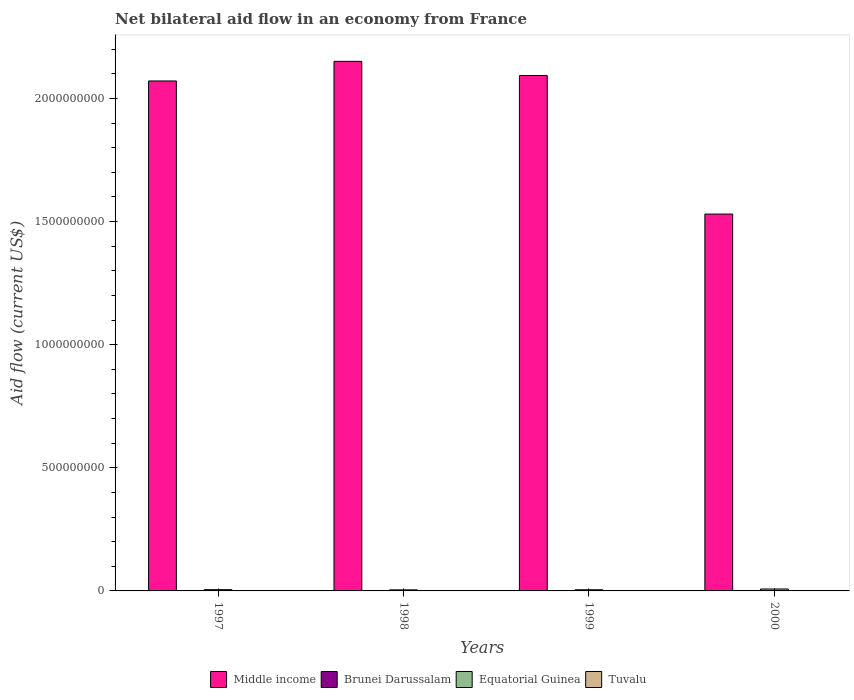How many bars are there on the 1st tick from the left?
Keep it short and to the point. 4. What is the net bilateral aid flow in Middle income in 1997?
Keep it short and to the point. 2.07e+09. Across all years, what is the minimum net bilateral aid flow in Equatorial Guinea?
Your response must be concise. 4.35e+06. What is the total net bilateral aid flow in Brunei Darussalam in the graph?
Ensure brevity in your answer.  1.51e+06. What is the difference between the net bilateral aid flow in Equatorial Guinea in 2000 and the net bilateral aid flow in Middle income in 1997?
Offer a terse response. -2.06e+09. What is the average net bilateral aid flow in Tuvalu per year?
Make the answer very short. 2.40e+05. In the year 1997, what is the difference between the net bilateral aid flow in Middle income and net bilateral aid flow in Tuvalu?
Provide a succinct answer. 2.07e+09. What is the ratio of the net bilateral aid flow in Equatorial Guinea in 1997 to that in 2000?
Make the answer very short. 0.66. Is the difference between the net bilateral aid flow in Middle income in 1998 and 2000 greater than the difference between the net bilateral aid flow in Tuvalu in 1998 and 2000?
Offer a very short reply. Yes. What is the difference between the highest and the second highest net bilateral aid flow in Tuvalu?
Make the answer very short. 10000. What is the difference between the highest and the lowest net bilateral aid flow in Equatorial Guinea?
Give a very brief answer. 3.53e+06. In how many years, is the net bilateral aid flow in Brunei Darussalam greater than the average net bilateral aid flow in Brunei Darussalam taken over all years?
Your response must be concise. 1. Is the sum of the net bilateral aid flow in Tuvalu in 1998 and 1999 greater than the maximum net bilateral aid flow in Brunei Darussalam across all years?
Offer a very short reply. No. What does the 3rd bar from the left in 1998 represents?
Your answer should be very brief. Equatorial Guinea. What does the 2nd bar from the right in 1998 represents?
Your answer should be very brief. Equatorial Guinea. Is it the case that in every year, the sum of the net bilateral aid flow in Middle income and net bilateral aid flow in Tuvalu is greater than the net bilateral aid flow in Brunei Darussalam?
Provide a short and direct response. Yes. Are all the bars in the graph horizontal?
Make the answer very short. No. Does the graph contain any zero values?
Give a very brief answer. No. Does the graph contain grids?
Keep it short and to the point. No. How many legend labels are there?
Your response must be concise. 4. What is the title of the graph?
Your response must be concise. Net bilateral aid flow in an economy from France. What is the Aid flow (current US$) of Middle income in 1997?
Provide a short and direct response. 2.07e+09. What is the Aid flow (current US$) in Equatorial Guinea in 1997?
Provide a succinct answer. 5.18e+06. What is the Aid flow (current US$) in Tuvalu in 1997?
Make the answer very short. 1.30e+05. What is the Aid flow (current US$) of Middle income in 1998?
Make the answer very short. 2.15e+09. What is the Aid flow (current US$) in Brunei Darussalam in 1998?
Offer a very short reply. 1.00e+05. What is the Aid flow (current US$) of Equatorial Guinea in 1998?
Your answer should be compact. 4.35e+06. What is the Aid flow (current US$) of Tuvalu in 1998?
Offer a very short reply. 2.80e+05. What is the Aid flow (current US$) in Middle income in 1999?
Your answer should be compact. 2.09e+09. What is the Aid flow (current US$) in Brunei Darussalam in 1999?
Your answer should be compact. 1.24e+06. What is the Aid flow (current US$) in Equatorial Guinea in 1999?
Ensure brevity in your answer.  4.74e+06. What is the Aid flow (current US$) of Middle income in 2000?
Offer a very short reply. 1.53e+09. What is the Aid flow (current US$) of Equatorial Guinea in 2000?
Your answer should be compact. 7.88e+06. Across all years, what is the maximum Aid flow (current US$) in Middle income?
Your answer should be compact. 2.15e+09. Across all years, what is the maximum Aid flow (current US$) in Brunei Darussalam?
Provide a succinct answer. 1.24e+06. Across all years, what is the maximum Aid flow (current US$) of Equatorial Guinea?
Provide a short and direct response. 7.88e+06. Across all years, what is the minimum Aid flow (current US$) in Middle income?
Your answer should be very brief. 1.53e+09. Across all years, what is the minimum Aid flow (current US$) of Equatorial Guinea?
Your answer should be compact. 4.35e+06. What is the total Aid flow (current US$) of Middle income in the graph?
Your answer should be very brief. 7.84e+09. What is the total Aid flow (current US$) of Brunei Darussalam in the graph?
Give a very brief answer. 1.51e+06. What is the total Aid flow (current US$) of Equatorial Guinea in the graph?
Your answer should be compact. 2.22e+07. What is the total Aid flow (current US$) in Tuvalu in the graph?
Ensure brevity in your answer.  9.60e+05. What is the difference between the Aid flow (current US$) of Middle income in 1997 and that in 1998?
Ensure brevity in your answer.  -7.96e+07. What is the difference between the Aid flow (current US$) of Equatorial Guinea in 1997 and that in 1998?
Offer a very short reply. 8.30e+05. What is the difference between the Aid flow (current US$) in Middle income in 1997 and that in 1999?
Make the answer very short. -2.21e+07. What is the difference between the Aid flow (current US$) in Brunei Darussalam in 1997 and that in 1999?
Keep it short and to the point. -1.17e+06. What is the difference between the Aid flow (current US$) in Equatorial Guinea in 1997 and that in 1999?
Ensure brevity in your answer.  4.40e+05. What is the difference between the Aid flow (current US$) in Tuvalu in 1997 and that in 1999?
Provide a short and direct response. -1.30e+05. What is the difference between the Aid flow (current US$) in Middle income in 1997 and that in 2000?
Offer a very short reply. 5.40e+08. What is the difference between the Aid flow (current US$) of Brunei Darussalam in 1997 and that in 2000?
Keep it short and to the point. -3.00e+04. What is the difference between the Aid flow (current US$) of Equatorial Guinea in 1997 and that in 2000?
Offer a very short reply. -2.70e+06. What is the difference between the Aid flow (current US$) in Middle income in 1998 and that in 1999?
Ensure brevity in your answer.  5.75e+07. What is the difference between the Aid flow (current US$) in Brunei Darussalam in 1998 and that in 1999?
Ensure brevity in your answer.  -1.14e+06. What is the difference between the Aid flow (current US$) of Equatorial Guinea in 1998 and that in 1999?
Ensure brevity in your answer.  -3.90e+05. What is the difference between the Aid flow (current US$) of Tuvalu in 1998 and that in 1999?
Your answer should be compact. 2.00e+04. What is the difference between the Aid flow (current US$) of Middle income in 1998 and that in 2000?
Give a very brief answer. 6.20e+08. What is the difference between the Aid flow (current US$) of Equatorial Guinea in 1998 and that in 2000?
Ensure brevity in your answer.  -3.53e+06. What is the difference between the Aid flow (current US$) of Middle income in 1999 and that in 2000?
Give a very brief answer. 5.63e+08. What is the difference between the Aid flow (current US$) in Brunei Darussalam in 1999 and that in 2000?
Your answer should be very brief. 1.14e+06. What is the difference between the Aid flow (current US$) in Equatorial Guinea in 1999 and that in 2000?
Keep it short and to the point. -3.14e+06. What is the difference between the Aid flow (current US$) of Tuvalu in 1999 and that in 2000?
Your answer should be compact. -3.00e+04. What is the difference between the Aid flow (current US$) of Middle income in 1997 and the Aid flow (current US$) of Brunei Darussalam in 1998?
Offer a very short reply. 2.07e+09. What is the difference between the Aid flow (current US$) in Middle income in 1997 and the Aid flow (current US$) in Equatorial Guinea in 1998?
Make the answer very short. 2.07e+09. What is the difference between the Aid flow (current US$) of Middle income in 1997 and the Aid flow (current US$) of Tuvalu in 1998?
Ensure brevity in your answer.  2.07e+09. What is the difference between the Aid flow (current US$) of Brunei Darussalam in 1997 and the Aid flow (current US$) of Equatorial Guinea in 1998?
Give a very brief answer. -4.28e+06. What is the difference between the Aid flow (current US$) of Equatorial Guinea in 1997 and the Aid flow (current US$) of Tuvalu in 1998?
Ensure brevity in your answer.  4.90e+06. What is the difference between the Aid flow (current US$) in Middle income in 1997 and the Aid flow (current US$) in Brunei Darussalam in 1999?
Keep it short and to the point. 2.07e+09. What is the difference between the Aid flow (current US$) in Middle income in 1997 and the Aid flow (current US$) in Equatorial Guinea in 1999?
Offer a terse response. 2.07e+09. What is the difference between the Aid flow (current US$) of Middle income in 1997 and the Aid flow (current US$) of Tuvalu in 1999?
Offer a terse response. 2.07e+09. What is the difference between the Aid flow (current US$) of Brunei Darussalam in 1997 and the Aid flow (current US$) of Equatorial Guinea in 1999?
Your answer should be very brief. -4.67e+06. What is the difference between the Aid flow (current US$) in Brunei Darussalam in 1997 and the Aid flow (current US$) in Tuvalu in 1999?
Ensure brevity in your answer.  -1.90e+05. What is the difference between the Aid flow (current US$) of Equatorial Guinea in 1997 and the Aid flow (current US$) of Tuvalu in 1999?
Keep it short and to the point. 4.92e+06. What is the difference between the Aid flow (current US$) of Middle income in 1997 and the Aid flow (current US$) of Brunei Darussalam in 2000?
Offer a very short reply. 2.07e+09. What is the difference between the Aid flow (current US$) in Middle income in 1997 and the Aid flow (current US$) in Equatorial Guinea in 2000?
Provide a short and direct response. 2.06e+09. What is the difference between the Aid flow (current US$) of Middle income in 1997 and the Aid flow (current US$) of Tuvalu in 2000?
Offer a very short reply. 2.07e+09. What is the difference between the Aid flow (current US$) of Brunei Darussalam in 1997 and the Aid flow (current US$) of Equatorial Guinea in 2000?
Your response must be concise. -7.81e+06. What is the difference between the Aid flow (current US$) of Equatorial Guinea in 1997 and the Aid flow (current US$) of Tuvalu in 2000?
Ensure brevity in your answer.  4.89e+06. What is the difference between the Aid flow (current US$) in Middle income in 1998 and the Aid flow (current US$) in Brunei Darussalam in 1999?
Your response must be concise. 2.15e+09. What is the difference between the Aid flow (current US$) of Middle income in 1998 and the Aid flow (current US$) of Equatorial Guinea in 1999?
Make the answer very short. 2.15e+09. What is the difference between the Aid flow (current US$) in Middle income in 1998 and the Aid flow (current US$) in Tuvalu in 1999?
Make the answer very short. 2.15e+09. What is the difference between the Aid flow (current US$) of Brunei Darussalam in 1998 and the Aid flow (current US$) of Equatorial Guinea in 1999?
Give a very brief answer. -4.64e+06. What is the difference between the Aid flow (current US$) in Brunei Darussalam in 1998 and the Aid flow (current US$) in Tuvalu in 1999?
Your answer should be very brief. -1.60e+05. What is the difference between the Aid flow (current US$) of Equatorial Guinea in 1998 and the Aid flow (current US$) of Tuvalu in 1999?
Ensure brevity in your answer.  4.09e+06. What is the difference between the Aid flow (current US$) of Middle income in 1998 and the Aid flow (current US$) of Brunei Darussalam in 2000?
Your response must be concise. 2.15e+09. What is the difference between the Aid flow (current US$) in Middle income in 1998 and the Aid flow (current US$) in Equatorial Guinea in 2000?
Give a very brief answer. 2.14e+09. What is the difference between the Aid flow (current US$) in Middle income in 1998 and the Aid flow (current US$) in Tuvalu in 2000?
Provide a short and direct response. 2.15e+09. What is the difference between the Aid flow (current US$) of Brunei Darussalam in 1998 and the Aid flow (current US$) of Equatorial Guinea in 2000?
Keep it short and to the point. -7.78e+06. What is the difference between the Aid flow (current US$) in Equatorial Guinea in 1998 and the Aid flow (current US$) in Tuvalu in 2000?
Your answer should be very brief. 4.06e+06. What is the difference between the Aid flow (current US$) of Middle income in 1999 and the Aid flow (current US$) of Brunei Darussalam in 2000?
Offer a terse response. 2.09e+09. What is the difference between the Aid flow (current US$) in Middle income in 1999 and the Aid flow (current US$) in Equatorial Guinea in 2000?
Your answer should be compact. 2.09e+09. What is the difference between the Aid flow (current US$) in Middle income in 1999 and the Aid flow (current US$) in Tuvalu in 2000?
Make the answer very short. 2.09e+09. What is the difference between the Aid flow (current US$) of Brunei Darussalam in 1999 and the Aid flow (current US$) of Equatorial Guinea in 2000?
Your answer should be compact. -6.64e+06. What is the difference between the Aid flow (current US$) in Brunei Darussalam in 1999 and the Aid flow (current US$) in Tuvalu in 2000?
Your response must be concise. 9.50e+05. What is the difference between the Aid flow (current US$) of Equatorial Guinea in 1999 and the Aid flow (current US$) of Tuvalu in 2000?
Provide a succinct answer. 4.45e+06. What is the average Aid flow (current US$) in Middle income per year?
Make the answer very short. 1.96e+09. What is the average Aid flow (current US$) of Brunei Darussalam per year?
Your answer should be very brief. 3.78e+05. What is the average Aid flow (current US$) in Equatorial Guinea per year?
Make the answer very short. 5.54e+06. What is the average Aid flow (current US$) of Tuvalu per year?
Provide a short and direct response. 2.40e+05. In the year 1997, what is the difference between the Aid flow (current US$) in Middle income and Aid flow (current US$) in Brunei Darussalam?
Provide a succinct answer. 2.07e+09. In the year 1997, what is the difference between the Aid flow (current US$) in Middle income and Aid flow (current US$) in Equatorial Guinea?
Give a very brief answer. 2.07e+09. In the year 1997, what is the difference between the Aid flow (current US$) in Middle income and Aid flow (current US$) in Tuvalu?
Your answer should be compact. 2.07e+09. In the year 1997, what is the difference between the Aid flow (current US$) in Brunei Darussalam and Aid flow (current US$) in Equatorial Guinea?
Keep it short and to the point. -5.11e+06. In the year 1997, what is the difference between the Aid flow (current US$) in Brunei Darussalam and Aid flow (current US$) in Tuvalu?
Offer a terse response. -6.00e+04. In the year 1997, what is the difference between the Aid flow (current US$) in Equatorial Guinea and Aid flow (current US$) in Tuvalu?
Ensure brevity in your answer.  5.05e+06. In the year 1998, what is the difference between the Aid flow (current US$) in Middle income and Aid flow (current US$) in Brunei Darussalam?
Keep it short and to the point. 2.15e+09. In the year 1998, what is the difference between the Aid flow (current US$) in Middle income and Aid flow (current US$) in Equatorial Guinea?
Provide a succinct answer. 2.15e+09. In the year 1998, what is the difference between the Aid flow (current US$) in Middle income and Aid flow (current US$) in Tuvalu?
Provide a succinct answer. 2.15e+09. In the year 1998, what is the difference between the Aid flow (current US$) of Brunei Darussalam and Aid flow (current US$) of Equatorial Guinea?
Offer a terse response. -4.25e+06. In the year 1998, what is the difference between the Aid flow (current US$) in Equatorial Guinea and Aid flow (current US$) in Tuvalu?
Offer a terse response. 4.07e+06. In the year 1999, what is the difference between the Aid flow (current US$) of Middle income and Aid flow (current US$) of Brunei Darussalam?
Your answer should be compact. 2.09e+09. In the year 1999, what is the difference between the Aid flow (current US$) of Middle income and Aid flow (current US$) of Equatorial Guinea?
Your response must be concise. 2.09e+09. In the year 1999, what is the difference between the Aid flow (current US$) in Middle income and Aid flow (current US$) in Tuvalu?
Your answer should be compact. 2.09e+09. In the year 1999, what is the difference between the Aid flow (current US$) of Brunei Darussalam and Aid flow (current US$) of Equatorial Guinea?
Your answer should be very brief. -3.50e+06. In the year 1999, what is the difference between the Aid flow (current US$) of Brunei Darussalam and Aid flow (current US$) of Tuvalu?
Keep it short and to the point. 9.80e+05. In the year 1999, what is the difference between the Aid flow (current US$) of Equatorial Guinea and Aid flow (current US$) of Tuvalu?
Offer a very short reply. 4.48e+06. In the year 2000, what is the difference between the Aid flow (current US$) in Middle income and Aid flow (current US$) in Brunei Darussalam?
Your answer should be very brief. 1.53e+09. In the year 2000, what is the difference between the Aid flow (current US$) in Middle income and Aid flow (current US$) in Equatorial Guinea?
Your answer should be very brief. 1.52e+09. In the year 2000, what is the difference between the Aid flow (current US$) in Middle income and Aid flow (current US$) in Tuvalu?
Offer a terse response. 1.53e+09. In the year 2000, what is the difference between the Aid flow (current US$) of Brunei Darussalam and Aid flow (current US$) of Equatorial Guinea?
Provide a succinct answer. -7.78e+06. In the year 2000, what is the difference between the Aid flow (current US$) in Brunei Darussalam and Aid flow (current US$) in Tuvalu?
Your answer should be very brief. -1.90e+05. In the year 2000, what is the difference between the Aid flow (current US$) in Equatorial Guinea and Aid flow (current US$) in Tuvalu?
Offer a very short reply. 7.59e+06. What is the ratio of the Aid flow (current US$) of Middle income in 1997 to that in 1998?
Provide a short and direct response. 0.96. What is the ratio of the Aid flow (current US$) of Equatorial Guinea in 1997 to that in 1998?
Make the answer very short. 1.19. What is the ratio of the Aid flow (current US$) in Tuvalu in 1997 to that in 1998?
Make the answer very short. 0.46. What is the ratio of the Aid flow (current US$) in Middle income in 1997 to that in 1999?
Your response must be concise. 0.99. What is the ratio of the Aid flow (current US$) of Brunei Darussalam in 1997 to that in 1999?
Keep it short and to the point. 0.06. What is the ratio of the Aid flow (current US$) in Equatorial Guinea in 1997 to that in 1999?
Offer a terse response. 1.09. What is the ratio of the Aid flow (current US$) of Tuvalu in 1997 to that in 1999?
Ensure brevity in your answer.  0.5. What is the ratio of the Aid flow (current US$) in Middle income in 1997 to that in 2000?
Your answer should be very brief. 1.35. What is the ratio of the Aid flow (current US$) in Brunei Darussalam in 1997 to that in 2000?
Your answer should be compact. 0.7. What is the ratio of the Aid flow (current US$) of Equatorial Guinea in 1997 to that in 2000?
Your answer should be very brief. 0.66. What is the ratio of the Aid flow (current US$) in Tuvalu in 1997 to that in 2000?
Keep it short and to the point. 0.45. What is the ratio of the Aid flow (current US$) in Middle income in 1998 to that in 1999?
Your response must be concise. 1.03. What is the ratio of the Aid flow (current US$) in Brunei Darussalam in 1998 to that in 1999?
Make the answer very short. 0.08. What is the ratio of the Aid flow (current US$) of Equatorial Guinea in 1998 to that in 1999?
Provide a succinct answer. 0.92. What is the ratio of the Aid flow (current US$) of Tuvalu in 1998 to that in 1999?
Offer a very short reply. 1.08. What is the ratio of the Aid flow (current US$) in Middle income in 1998 to that in 2000?
Ensure brevity in your answer.  1.41. What is the ratio of the Aid flow (current US$) of Brunei Darussalam in 1998 to that in 2000?
Your answer should be very brief. 1. What is the ratio of the Aid flow (current US$) of Equatorial Guinea in 1998 to that in 2000?
Ensure brevity in your answer.  0.55. What is the ratio of the Aid flow (current US$) of Tuvalu in 1998 to that in 2000?
Your answer should be very brief. 0.97. What is the ratio of the Aid flow (current US$) in Middle income in 1999 to that in 2000?
Offer a terse response. 1.37. What is the ratio of the Aid flow (current US$) of Brunei Darussalam in 1999 to that in 2000?
Make the answer very short. 12.4. What is the ratio of the Aid flow (current US$) in Equatorial Guinea in 1999 to that in 2000?
Your answer should be very brief. 0.6. What is the ratio of the Aid flow (current US$) of Tuvalu in 1999 to that in 2000?
Give a very brief answer. 0.9. What is the difference between the highest and the second highest Aid flow (current US$) in Middle income?
Ensure brevity in your answer.  5.75e+07. What is the difference between the highest and the second highest Aid flow (current US$) of Brunei Darussalam?
Keep it short and to the point. 1.14e+06. What is the difference between the highest and the second highest Aid flow (current US$) of Equatorial Guinea?
Keep it short and to the point. 2.70e+06. What is the difference between the highest and the lowest Aid flow (current US$) of Middle income?
Give a very brief answer. 6.20e+08. What is the difference between the highest and the lowest Aid flow (current US$) in Brunei Darussalam?
Your answer should be very brief. 1.17e+06. What is the difference between the highest and the lowest Aid flow (current US$) in Equatorial Guinea?
Offer a terse response. 3.53e+06. What is the difference between the highest and the lowest Aid flow (current US$) of Tuvalu?
Offer a terse response. 1.60e+05. 